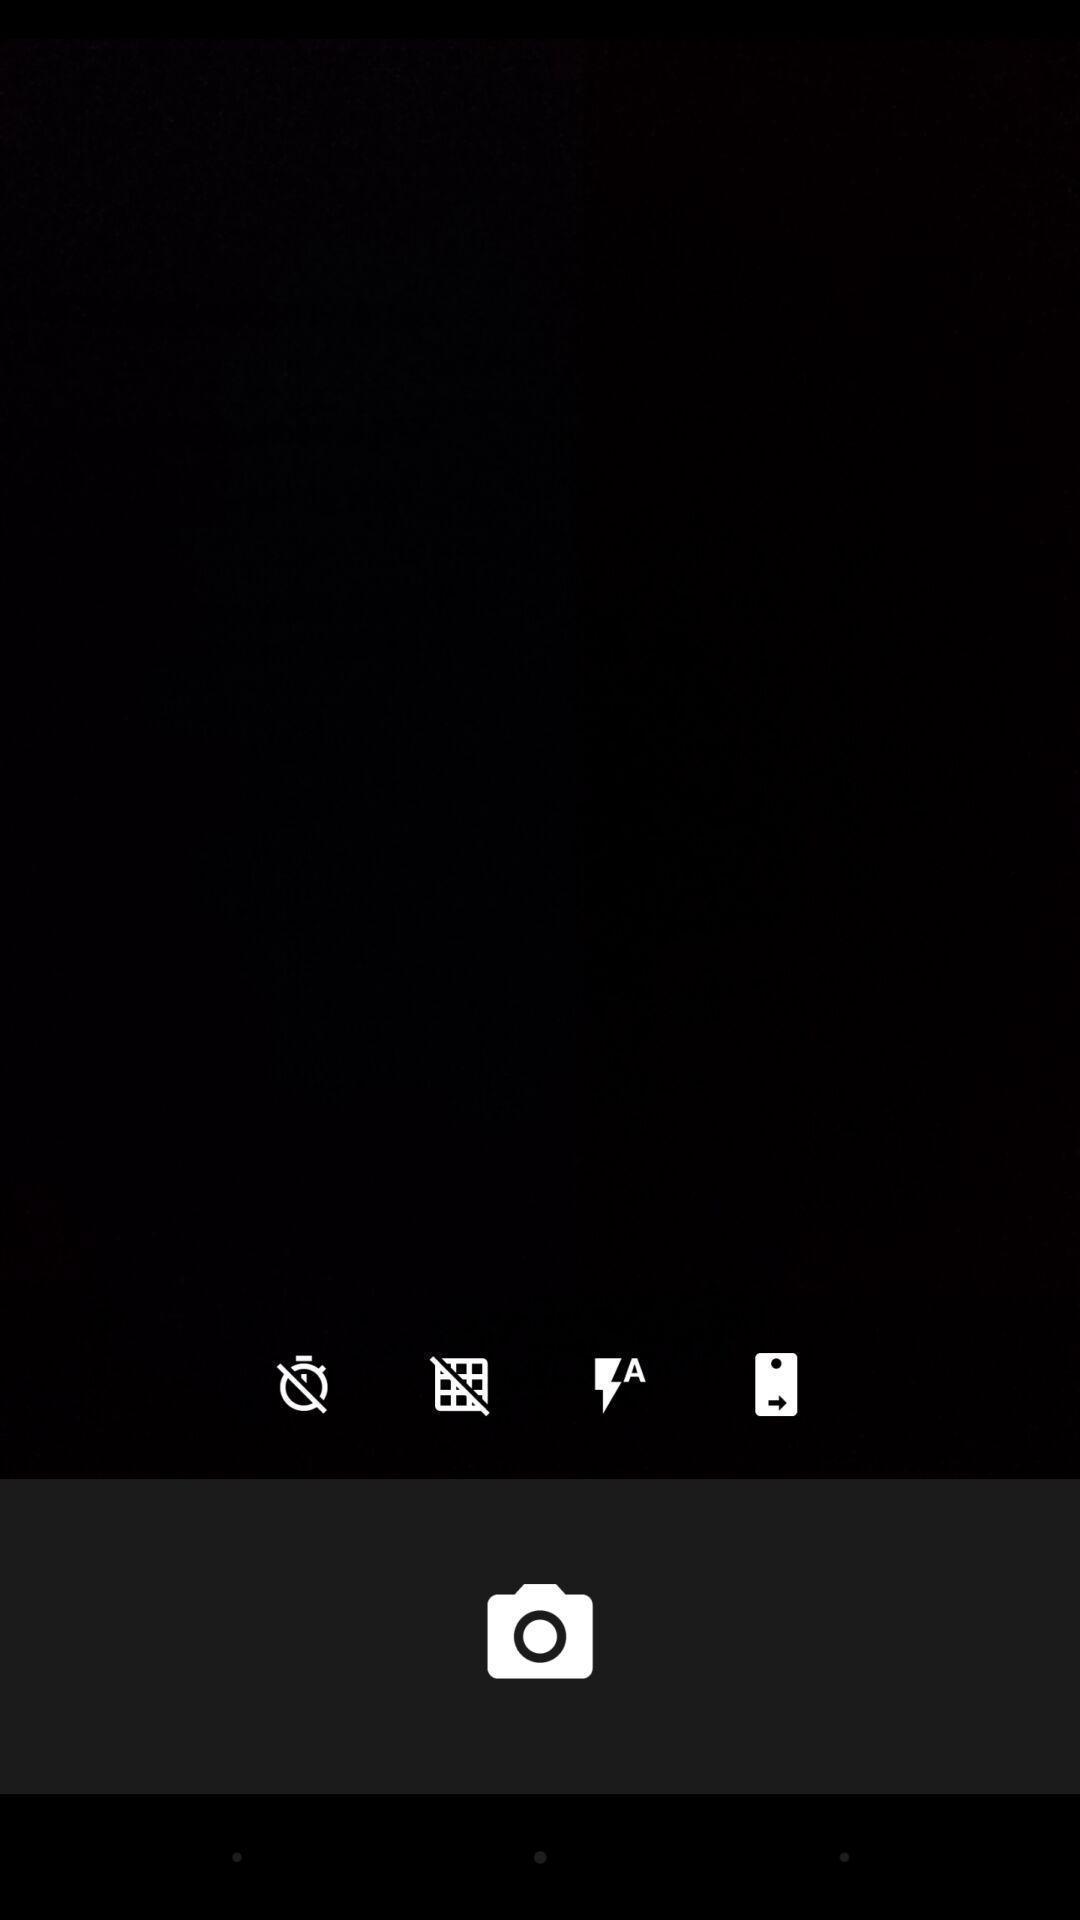Explain the elements present in this screenshot. Page displaying the camera button. 